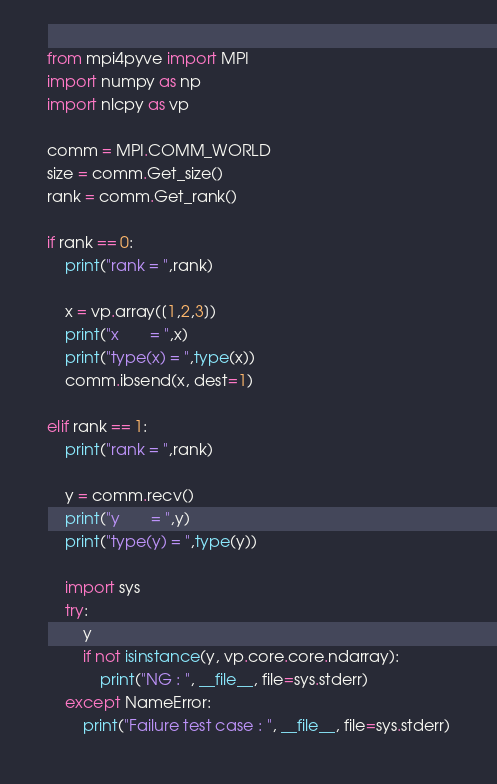Convert code to text. <code><loc_0><loc_0><loc_500><loc_500><_Python_>from mpi4pyve import MPI
import numpy as np
import nlcpy as vp

comm = MPI.COMM_WORLD
size = comm.Get_size()
rank = comm.Get_rank()

if rank == 0:
    print("rank = ",rank)

    x = vp.array([1,2,3])
    print("x       = ",x)
    print("type(x) = ",type(x))
    comm.ibsend(x, dest=1)

elif rank == 1:
    print("rank = ",rank)

    y = comm.recv()
    print("y       = ",y)
    print("type(y) = ",type(y)) 

    import sys
    try:
        y
        if not isinstance(y, vp.core.core.ndarray):
            print("NG : ", __file__, file=sys.stderr)
    except NameError:
        print("Failure test case : ", __file__, file=sys.stderr)
</code> 